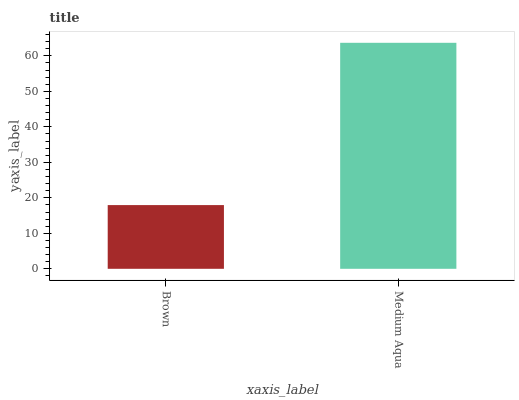Is Brown the minimum?
Answer yes or no. Yes. Is Medium Aqua the maximum?
Answer yes or no. Yes. Is Medium Aqua the minimum?
Answer yes or no. No. Is Medium Aqua greater than Brown?
Answer yes or no. Yes. Is Brown less than Medium Aqua?
Answer yes or no. Yes. Is Brown greater than Medium Aqua?
Answer yes or no. No. Is Medium Aqua less than Brown?
Answer yes or no. No. Is Medium Aqua the high median?
Answer yes or no. Yes. Is Brown the low median?
Answer yes or no. Yes. Is Brown the high median?
Answer yes or no. No. Is Medium Aqua the low median?
Answer yes or no. No. 